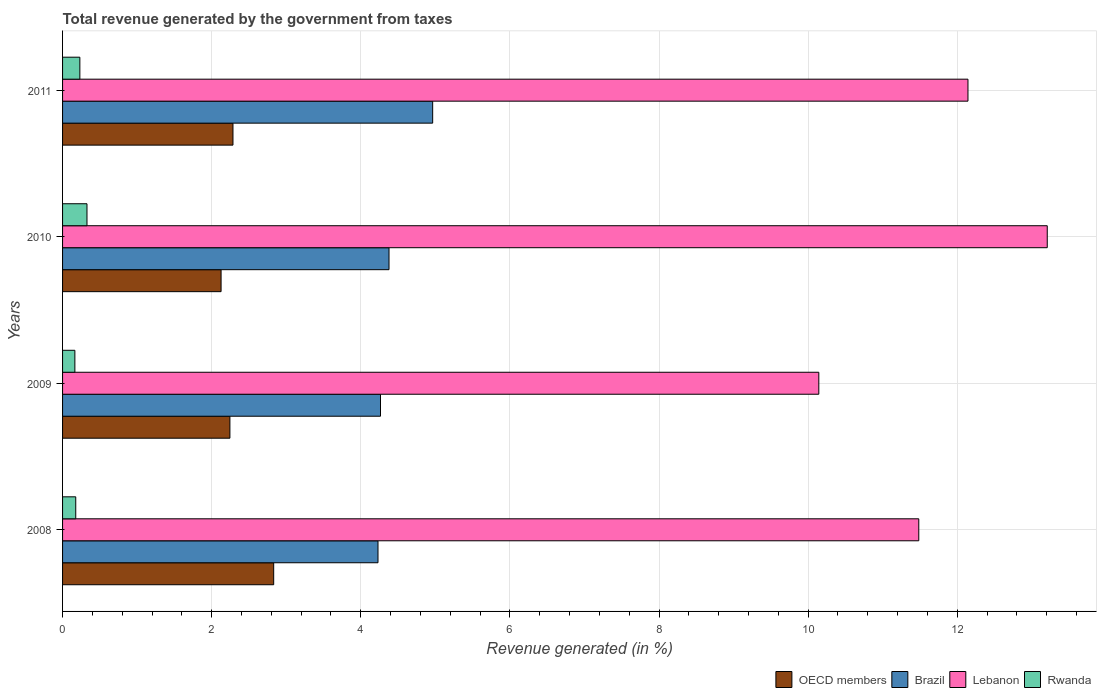How many different coloured bars are there?
Provide a short and direct response. 4. Are the number of bars per tick equal to the number of legend labels?
Provide a succinct answer. Yes. How many bars are there on the 2nd tick from the top?
Your answer should be very brief. 4. How many bars are there on the 4th tick from the bottom?
Keep it short and to the point. 4. In how many cases, is the number of bars for a given year not equal to the number of legend labels?
Offer a terse response. 0. What is the total revenue generated in Brazil in 2010?
Your response must be concise. 4.38. Across all years, what is the maximum total revenue generated in OECD members?
Your response must be concise. 2.83. Across all years, what is the minimum total revenue generated in OECD members?
Your answer should be very brief. 2.13. In which year was the total revenue generated in OECD members maximum?
Your answer should be compact. 2008. What is the total total revenue generated in Brazil in the graph?
Ensure brevity in your answer.  17.84. What is the difference between the total revenue generated in OECD members in 2008 and that in 2011?
Give a very brief answer. 0.55. What is the difference between the total revenue generated in Brazil in 2010 and the total revenue generated in Lebanon in 2011?
Your answer should be compact. -7.77. What is the average total revenue generated in Rwanda per year?
Your response must be concise. 0.23. In the year 2009, what is the difference between the total revenue generated in Lebanon and total revenue generated in Brazil?
Give a very brief answer. 5.88. In how many years, is the total revenue generated in Lebanon greater than 13.2 %?
Give a very brief answer. 1. What is the ratio of the total revenue generated in Brazil in 2008 to that in 2010?
Ensure brevity in your answer.  0.97. What is the difference between the highest and the second highest total revenue generated in OECD members?
Your answer should be compact. 0.55. What is the difference between the highest and the lowest total revenue generated in Rwanda?
Make the answer very short. 0.16. What does the 4th bar from the top in 2010 represents?
Your answer should be very brief. OECD members. What does the 4th bar from the bottom in 2009 represents?
Your answer should be compact. Rwanda. How many bars are there?
Your response must be concise. 16. Are all the bars in the graph horizontal?
Give a very brief answer. Yes. How many years are there in the graph?
Provide a short and direct response. 4. Does the graph contain any zero values?
Your answer should be very brief. No. Does the graph contain grids?
Keep it short and to the point. Yes. Where does the legend appear in the graph?
Keep it short and to the point. Bottom right. What is the title of the graph?
Your answer should be compact. Total revenue generated by the government from taxes. Does "Indonesia" appear as one of the legend labels in the graph?
Offer a terse response. No. What is the label or title of the X-axis?
Ensure brevity in your answer.  Revenue generated (in %). What is the label or title of the Y-axis?
Provide a succinct answer. Years. What is the Revenue generated (in %) in OECD members in 2008?
Your answer should be compact. 2.83. What is the Revenue generated (in %) of Brazil in 2008?
Give a very brief answer. 4.23. What is the Revenue generated (in %) in Lebanon in 2008?
Your answer should be very brief. 11.48. What is the Revenue generated (in %) of Rwanda in 2008?
Make the answer very short. 0.18. What is the Revenue generated (in %) in OECD members in 2009?
Make the answer very short. 2.24. What is the Revenue generated (in %) of Brazil in 2009?
Offer a terse response. 4.26. What is the Revenue generated (in %) of Lebanon in 2009?
Offer a very short reply. 10.14. What is the Revenue generated (in %) in Rwanda in 2009?
Provide a succinct answer. 0.17. What is the Revenue generated (in %) of OECD members in 2010?
Your answer should be very brief. 2.13. What is the Revenue generated (in %) in Brazil in 2010?
Offer a terse response. 4.38. What is the Revenue generated (in %) of Lebanon in 2010?
Offer a terse response. 13.21. What is the Revenue generated (in %) of Rwanda in 2010?
Your answer should be compact. 0.33. What is the Revenue generated (in %) in OECD members in 2011?
Your answer should be compact. 2.29. What is the Revenue generated (in %) in Brazil in 2011?
Keep it short and to the point. 4.96. What is the Revenue generated (in %) in Lebanon in 2011?
Make the answer very short. 12.14. What is the Revenue generated (in %) of Rwanda in 2011?
Make the answer very short. 0.23. Across all years, what is the maximum Revenue generated (in %) in OECD members?
Offer a very short reply. 2.83. Across all years, what is the maximum Revenue generated (in %) in Brazil?
Your answer should be very brief. 4.96. Across all years, what is the maximum Revenue generated (in %) of Lebanon?
Your response must be concise. 13.21. Across all years, what is the maximum Revenue generated (in %) in Rwanda?
Offer a terse response. 0.33. Across all years, what is the minimum Revenue generated (in %) in OECD members?
Your response must be concise. 2.13. Across all years, what is the minimum Revenue generated (in %) in Brazil?
Give a very brief answer. 4.23. Across all years, what is the minimum Revenue generated (in %) of Lebanon?
Offer a terse response. 10.14. Across all years, what is the minimum Revenue generated (in %) of Rwanda?
Your answer should be compact. 0.17. What is the total Revenue generated (in %) in OECD members in the graph?
Keep it short and to the point. 9.49. What is the total Revenue generated (in %) in Brazil in the graph?
Provide a short and direct response. 17.84. What is the total Revenue generated (in %) of Lebanon in the graph?
Provide a succinct answer. 46.98. What is the total Revenue generated (in %) of Rwanda in the graph?
Your response must be concise. 0.9. What is the difference between the Revenue generated (in %) in OECD members in 2008 and that in 2009?
Ensure brevity in your answer.  0.59. What is the difference between the Revenue generated (in %) of Brazil in 2008 and that in 2009?
Provide a short and direct response. -0.03. What is the difference between the Revenue generated (in %) of Lebanon in 2008 and that in 2009?
Offer a terse response. 1.34. What is the difference between the Revenue generated (in %) in Rwanda in 2008 and that in 2009?
Ensure brevity in your answer.  0.01. What is the difference between the Revenue generated (in %) of OECD members in 2008 and that in 2010?
Ensure brevity in your answer.  0.71. What is the difference between the Revenue generated (in %) in Brazil in 2008 and that in 2010?
Provide a short and direct response. -0.15. What is the difference between the Revenue generated (in %) in Lebanon in 2008 and that in 2010?
Your response must be concise. -1.72. What is the difference between the Revenue generated (in %) of Rwanda in 2008 and that in 2010?
Offer a terse response. -0.15. What is the difference between the Revenue generated (in %) of OECD members in 2008 and that in 2011?
Provide a short and direct response. 0.55. What is the difference between the Revenue generated (in %) in Brazil in 2008 and that in 2011?
Provide a short and direct response. -0.73. What is the difference between the Revenue generated (in %) of Lebanon in 2008 and that in 2011?
Your response must be concise. -0.66. What is the difference between the Revenue generated (in %) in Rwanda in 2008 and that in 2011?
Provide a short and direct response. -0.06. What is the difference between the Revenue generated (in %) in OECD members in 2009 and that in 2010?
Your answer should be very brief. 0.12. What is the difference between the Revenue generated (in %) of Brazil in 2009 and that in 2010?
Provide a succinct answer. -0.11. What is the difference between the Revenue generated (in %) in Lebanon in 2009 and that in 2010?
Your response must be concise. -3.06. What is the difference between the Revenue generated (in %) of Rwanda in 2009 and that in 2010?
Provide a succinct answer. -0.16. What is the difference between the Revenue generated (in %) of OECD members in 2009 and that in 2011?
Provide a succinct answer. -0.04. What is the difference between the Revenue generated (in %) in Brazil in 2009 and that in 2011?
Give a very brief answer. -0.7. What is the difference between the Revenue generated (in %) in Lebanon in 2009 and that in 2011?
Provide a short and direct response. -2. What is the difference between the Revenue generated (in %) of Rwanda in 2009 and that in 2011?
Ensure brevity in your answer.  -0.07. What is the difference between the Revenue generated (in %) in OECD members in 2010 and that in 2011?
Make the answer very short. -0.16. What is the difference between the Revenue generated (in %) in Brazil in 2010 and that in 2011?
Ensure brevity in your answer.  -0.59. What is the difference between the Revenue generated (in %) in Lebanon in 2010 and that in 2011?
Give a very brief answer. 1.06. What is the difference between the Revenue generated (in %) of Rwanda in 2010 and that in 2011?
Keep it short and to the point. 0.1. What is the difference between the Revenue generated (in %) of OECD members in 2008 and the Revenue generated (in %) of Brazil in 2009?
Provide a succinct answer. -1.43. What is the difference between the Revenue generated (in %) of OECD members in 2008 and the Revenue generated (in %) of Lebanon in 2009?
Ensure brevity in your answer.  -7.31. What is the difference between the Revenue generated (in %) of OECD members in 2008 and the Revenue generated (in %) of Rwanda in 2009?
Provide a short and direct response. 2.67. What is the difference between the Revenue generated (in %) in Brazil in 2008 and the Revenue generated (in %) in Lebanon in 2009?
Offer a very short reply. -5.91. What is the difference between the Revenue generated (in %) in Brazil in 2008 and the Revenue generated (in %) in Rwanda in 2009?
Provide a short and direct response. 4.07. What is the difference between the Revenue generated (in %) in Lebanon in 2008 and the Revenue generated (in %) in Rwanda in 2009?
Make the answer very short. 11.32. What is the difference between the Revenue generated (in %) in OECD members in 2008 and the Revenue generated (in %) in Brazil in 2010?
Keep it short and to the point. -1.55. What is the difference between the Revenue generated (in %) in OECD members in 2008 and the Revenue generated (in %) in Lebanon in 2010?
Keep it short and to the point. -10.38. What is the difference between the Revenue generated (in %) of OECD members in 2008 and the Revenue generated (in %) of Rwanda in 2010?
Make the answer very short. 2.5. What is the difference between the Revenue generated (in %) in Brazil in 2008 and the Revenue generated (in %) in Lebanon in 2010?
Provide a short and direct response. -8.98. What is the difference between the Revenue generated (in %) of Brazil in 2008 and the Revenue generated (in %) of Rwanda in 2010?
Provide a succinct answer. 3.9. What is the difference between the Revenue generated (in %) in Lebanon in 2008 and the Revenue generated (in %) in Rwanda in 2010?
Provide a succinct answer. 11.16. What is the difference between the Revenue generated (in %) of OECD members in 2008 and the Revenue generated (in %) of Brazil in 2011?
Provide a succinct answer. -2.13. What is the difference between the Revenue generated (in %) of OECD members in 2008 and the Revenue generated (in %) of Lebanon in 2011?
Provide a succinct answer. -9.31. What is the difference between the Revenue generated (in %) of OECD members in 2008 and the Revenue generated (in %) of Rwanda in 2011?
Ensure brevity in your answer.  2.6. What is the difference between the Revenue generated (in %) in Brazil in 2008 and the Revenue generated (in %) in Lebanon in 2011?
Make the answer very short. -7.91. What is the difference between the Revenue generated (in %) of Brazil in 2008 and the Revenue generated (in %) of Rwanda in 2011?
Keep it short and to the point. 4. What is the difference between the Revenue generated (in %) of Lebanon in 2008 and the Revenue generated (in %) of Rwanda in 2011?
Offer a terse response. 11.25. What is the difference between the Revenue generated (in %) in OECD members in 2009 and the Revenue generated (in %) in Brazil in 2010?
Keep it short and to the point. -2.13. What is the difference between the Revenue generated (in %) in OECD members in 2009 and the Revenue generated (in %) in Lebanon in 2010?
Your answer should be very brief. -10.96. What is the difference between the Revenue generated (in %) of OECD members in 2009 and the Revenue generated (in %) of Rwanda in 2010?
Offer a very short reply. 1.92. What is the difference between the Revenue generated (in %) in Brazil in 2009 and the Revenue generated (in %) in Lebanon in 2010?
Keep it short and to the point. -8.94. What is the difference between the Revenue generated (in %) in Brazil in 2009 and the Revenue generated (in %) in Rwanda in 2010?
Make the answer very short. 3.94. What is the difference between the Revenue generated (in %) in Lebanon in 2009 and the Revenue generated (in %) in Rwanda in 2010?
Offer a very short reply. 9.82. What is the difference between the Revenue generated (in %) in OECD members in 2009 and the Revenue generated (in %) in Brazil in 2011?
Your answer should be very brief. -2.72. What is the difference between the Revenue generated (in %) in OECD members in 2009 and the Revenue generated (in %) in Lebanon in 2011?
Keep it short and to the point. -9.9. What is the difference between the Revenue generated (in %) in OECD members in 2009 and the Revenue generated (in %) in Rwanda in 2011?
Make the answer very short. 2.01. What is the difference between the Revenue generated (in %) of Brazil in 2009 and the Revenue generated (in %) of Lebanon in 2011?
Provide a succinct answer. -7.88. What is the difference between the Revenue generated (in %) of Brazil in 2009 and the Revenue generated (in %) of Rwanda in 2011?
Your answer should be very brief. 4.03. What is the difference between the Revenue generated (in %) in Lebanon in 2009 and the Revenue generated (in %) in Rwanda in 2011?
Ensure brevity in your answer.  9.91. What is the difference between the Revenue generated (in %) in OECD members in 2010 and the Revenue generated (in %) in Brazil in 2011?
Your response must be concise. -2.84. What is the difference between the Revenue generated (in %) in OECD members in 2010 and the Revenue generated (in %) in Lebanon in 2011?
Your answer should be compact. -10.02. What is the difference between the Revenue generated (in %) in OECD members in 2010 and the Revenue generated (in %) in Rwanda in 2011?
Offer a very short reply. 1.89. What is the difference between the Revenue generated (in %) in Brazil in 2010 and the Revenue generated (in %) in Lebanon in 2011?
Your answer should be very brief. -7.77. What is the difference between the Revenue generated (in %) of Brazil in 2010 and the Revenue generated (in %) of Rwanda in 2011?
Offer a terse response. 4.15. What is the difference between the Revenue generated (in %) in Lebanon in 2010 and the Revenue generated (in %) in Rwanda in 2011?
Your response must be concise. 12.97. What is the average Revenue generated (in %) of OECD members per year?
Your response must be concise. 2.37. What is the average Revenue generated (in %) of Brazil per year?
Your answer should be compact. 4.46. What is the average Revenue generated (in %) in Lebanon per year?
Ensure brevity in your answer.  11.74. What is the average Revenue generated (in %) in Rwanda per year?
Your answer should be very brief. 0.23. In the year 2008, what is the difference between the Revenue generated (in %) in OECD members and Revenue generated (in %) in Brazil?
Make the answer very short. -1.4. In the year 2008, what is the difference between the Revenue generated (in %) in OECD members and Revenue generated (in %) in Lebanon?
Make the answer very short. -8.65. In the year 2008, what is the difference between the Revenue generated (in %) in OECD members and Revenue generated (in %) in Rwanda?
Ensure brevity in your answer.  2.65. In the year 2008, what is the difference between the Revenue generated (in %) of Brazil and Revenue generated (in %) of Lebanon?
Make the answer very short. -7.25. In the year 2008, what is the difference between the Revenue generated (in %) of Brazil and Revenue generated (in %) of Rwanda?
Make the answer very short. 4.05. In the year 2008, what is the difference between the Revenue generated (in %) in Lebanon and Revenue generated (in %) in Rwanda?
Your answer should be compact. 11.31. In the year 2009, what is the difference between the Revenue generated (in %) in OECD members and Revenue generated (in %) in Brazil?
Your answer should be compact. -2.02. In the year 2009, what is the difference between the Revenue generated (in %) in OECD members and Revenue generated (in %) in Lebanon?
Ensure brevity in your answer.  -7.9. In the year 2009, what is the difference between the Revenue generated (in %) in OECD members and Revenue generated (in %) in Rwanda?
Your answer should be very brief. 2.08. In the year 2009, what is the difference between the Revenue generated (in %) of Brazil and Revenue generated (in %) of Lebanon?
Ensure brevity in your answer.  -5.88. In the year 2009, what is the difference between the Revenue generated (in %) of Brazil and Revenue generated (in %) of Rwanda?
Offer a terse response. 4.1. In the year 2009, what is the difference between the Revenue generated (in %) in Lebanon and Revenue generated (in %) in Rwanda?
Your answer should be very brief. 9.98. In the year 2010, what is the difference between the Revenue generated (in %) of OECD members and Revenue generated (in %) of Brazil?
Ensure brevity in your answer.  -2.25. In the year 2010, what is the difference between the Revenue generated (in %) of OECD members and Revenue generated (in %) of Lebanon?
Provide a succinct answer. -11.08. In the year 2010, what is the difference between the Revenue generated (in %) in OECD members and Revenue generated (in %) in Rwanda?
Keep it short and to the point. 1.8. In the year 2010, what is the difference between the Revenue generated (in %) of Brazil and Revenue generated (in %) of Lebanon?
Your answer should be compact. -8.83. In the year 2010, what is the difference between the Revenue generated (in %) of Brazil and Revenue generated (in %) of Rwanda?
Keep it short and to the point. 4.05. In the year 2010, what is the difference between the Revenue generated (in %) of Lebanon and Revenue generated (in %) of Rwanda?
Keep it short and to the point. 12.88. In the year 2011, what is the difference between the Revenue generated (in %) in OECD members and Revenue generated (in %) in Brazil?
Provide a short and direct response. -2.68. In the year 2011, what is the difference between the Revenue generated (in %) in OECD members and Revenue generated (in %) in Lebanon?
Provide a succinct answer. -9.86. In the year 2011, what is the difference between the Revenue generated (in %) in OECD members and Revenue generated (in %) in Rwanda?
Give a very brief answer. 2.05. In the year 2011, what is the difference between the Revenue generated (in %) of Brazil and Revenue generated (in %) of Lebanon?
Give a very brief answer. -7.18. In the year 2011, what is the difference between the Revenue generated (in %) of Brazil and Revenue generated (in %) of Rwanda?
Ensure brevity in your answer.  4.73. In the year 2011, what is the difference between the Revenue generated (in %) of Lebanon and Revenue generated (in %) of Rwanda?
Ensure brevity in your answer.  11.91. What is the ratio of the Revenue generated (in %) in OECD members in 2008 to that in 2009?
Give a very brief answer. 1.26. What is the ratio of the Revenue generated (in %) in Brazil in 2008 to that in 2009?
Your response must be concise. 0.99. What is the ratio of the Revenue generated (in %) of Lebanon in 2008 to that in 2009?
Your response must be concise. 1.13. What is the ratio of the Revenue generated (in %) of Rwanda in 2008 to that in 2009?
Offer a very short reply. 1.07. What is the ratio of the Revenue generated (in %) in OECD members in 2008 to that in 2010?
Give a very brief answer. 1.33. What is the ratio of the Revenue generated (in %) of Brazil in 2008 to that in 2010?
Make the answer very short. 0.97. What is the ratio of the Revenue generated (in %) of Lebanon in 2008 to that in 2010?
Offer a very short reply. 0.87. What is the ratio of the Revenue generated (in %) in Rwanda in 2008 to that in 2010?
Offer a terse response. 0.54. What is the ratio of the Revenue generated (in %) in OECD members in 2008 to that in 2011?
Your answer should be very brief. 1.24. What is the ratio of the Revenue generated (in %) of Brazil in 2008 to that in 2011?
Your response must be concise. 0.85. What is the ratio of the Revenue generated (in %) of Lebanon in 2008 to that in 2011?
Provide a short and direct response. 0.95. What is the ratio of the Revenue generated (in %) in Rwanda in 2008 to that in 2011?
Your answer should be compact. 0.76. What is the ratio of the Revenue generated (in %) in OECD members in 2009 to that in 2010?
Make the answer very short. 1.06. What is the ratio of the Revenue generated (in %) in Brazil in 2009 to that in 2010?
Give a very brief answer. 0.97. What is the ratio of the Revenue generated (in %) in Lebanon in 2009 to that in 2010?
Your response must be concise. 0.77. What is the ratio of the Revenue generated (in %) of Rwanda in 2009 to that in 2010?
Provide a succinct answer. 0.5. What is the ratio of the Revenue generated (in %) in Brazil in 2009 to that in 2011?
Ensure brevity in your answer.  0.86. What is the ratio of the Revenue generated (in %) of Lebanon in 2009 to that in 2011?
Offer a very short reply. 0.84. What is the ratio of the Revenue generated (in %) of Rwanda in 2009 to that in 2011?
Your answer should be very brief. 0.71. What is the ratio of the Revenue generated (in %) of OECD members in 2010 to that in 2011?
Your answer should be very brief. 0.93. What is the ratio of the Revenue generated (in %) of Brazil in 2010 to that in 2011?
Your answer should be compact. 0.88. What is the ratio of the Revenue generated (in %) in Lebanon in 2010 to that in 2011?
Offer a terse response. 1.09. What is the ratio of the Revenue generated (in %) of Rwanda in 2010 to that in 2011?
Provide a short and direct response. 1.41. What is the difference between the highest and the second highest Revenue generated (in %) in OECD members?
Provide a short and direct response. 0.55. What is the difference between the highest and the second highest Revenue generated (in %) in Brazil?
Offer a terse response. 0.59. What is the difference between the highest and the second highest Revenue generated (in %) in Lebanon?
Offer a very short reply. 1.06. What is the difference between the highest and the second highest Revenue generated (in %) of Rwanda?
Provide a succinct answer. 0.1. What is the difference between the highest and the lowest Revenue generated (in %) of OECD members?
Ensure brevity in your answer.  0.71. What is the difference between the highest and the lowest Revenue generated (in %) in Brazil?
Offer a terse response. 0.73. What is the difference between the highest and the lowest Revenue generated (in %) of Lebanon?
Your answer should be very brief. 3.06. What is the difference between the highest and the lowest Revenue generated (in %) of Rwanda?
Give a very brief answer. 0.16. 